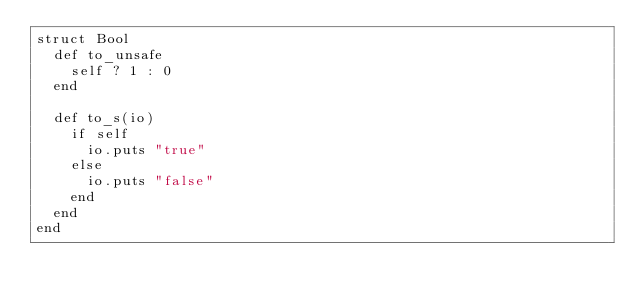Convert code to text. <code><loc_0><loc_0><loc_500><loc_500><_Crystal_>struct Bool
  def to_unsafe
    self ? 1 : 0
  end

  def to_s(io)
    if self
      io.puts "true"
    else
      io.puts "false"
    end
  end
end
</code> 